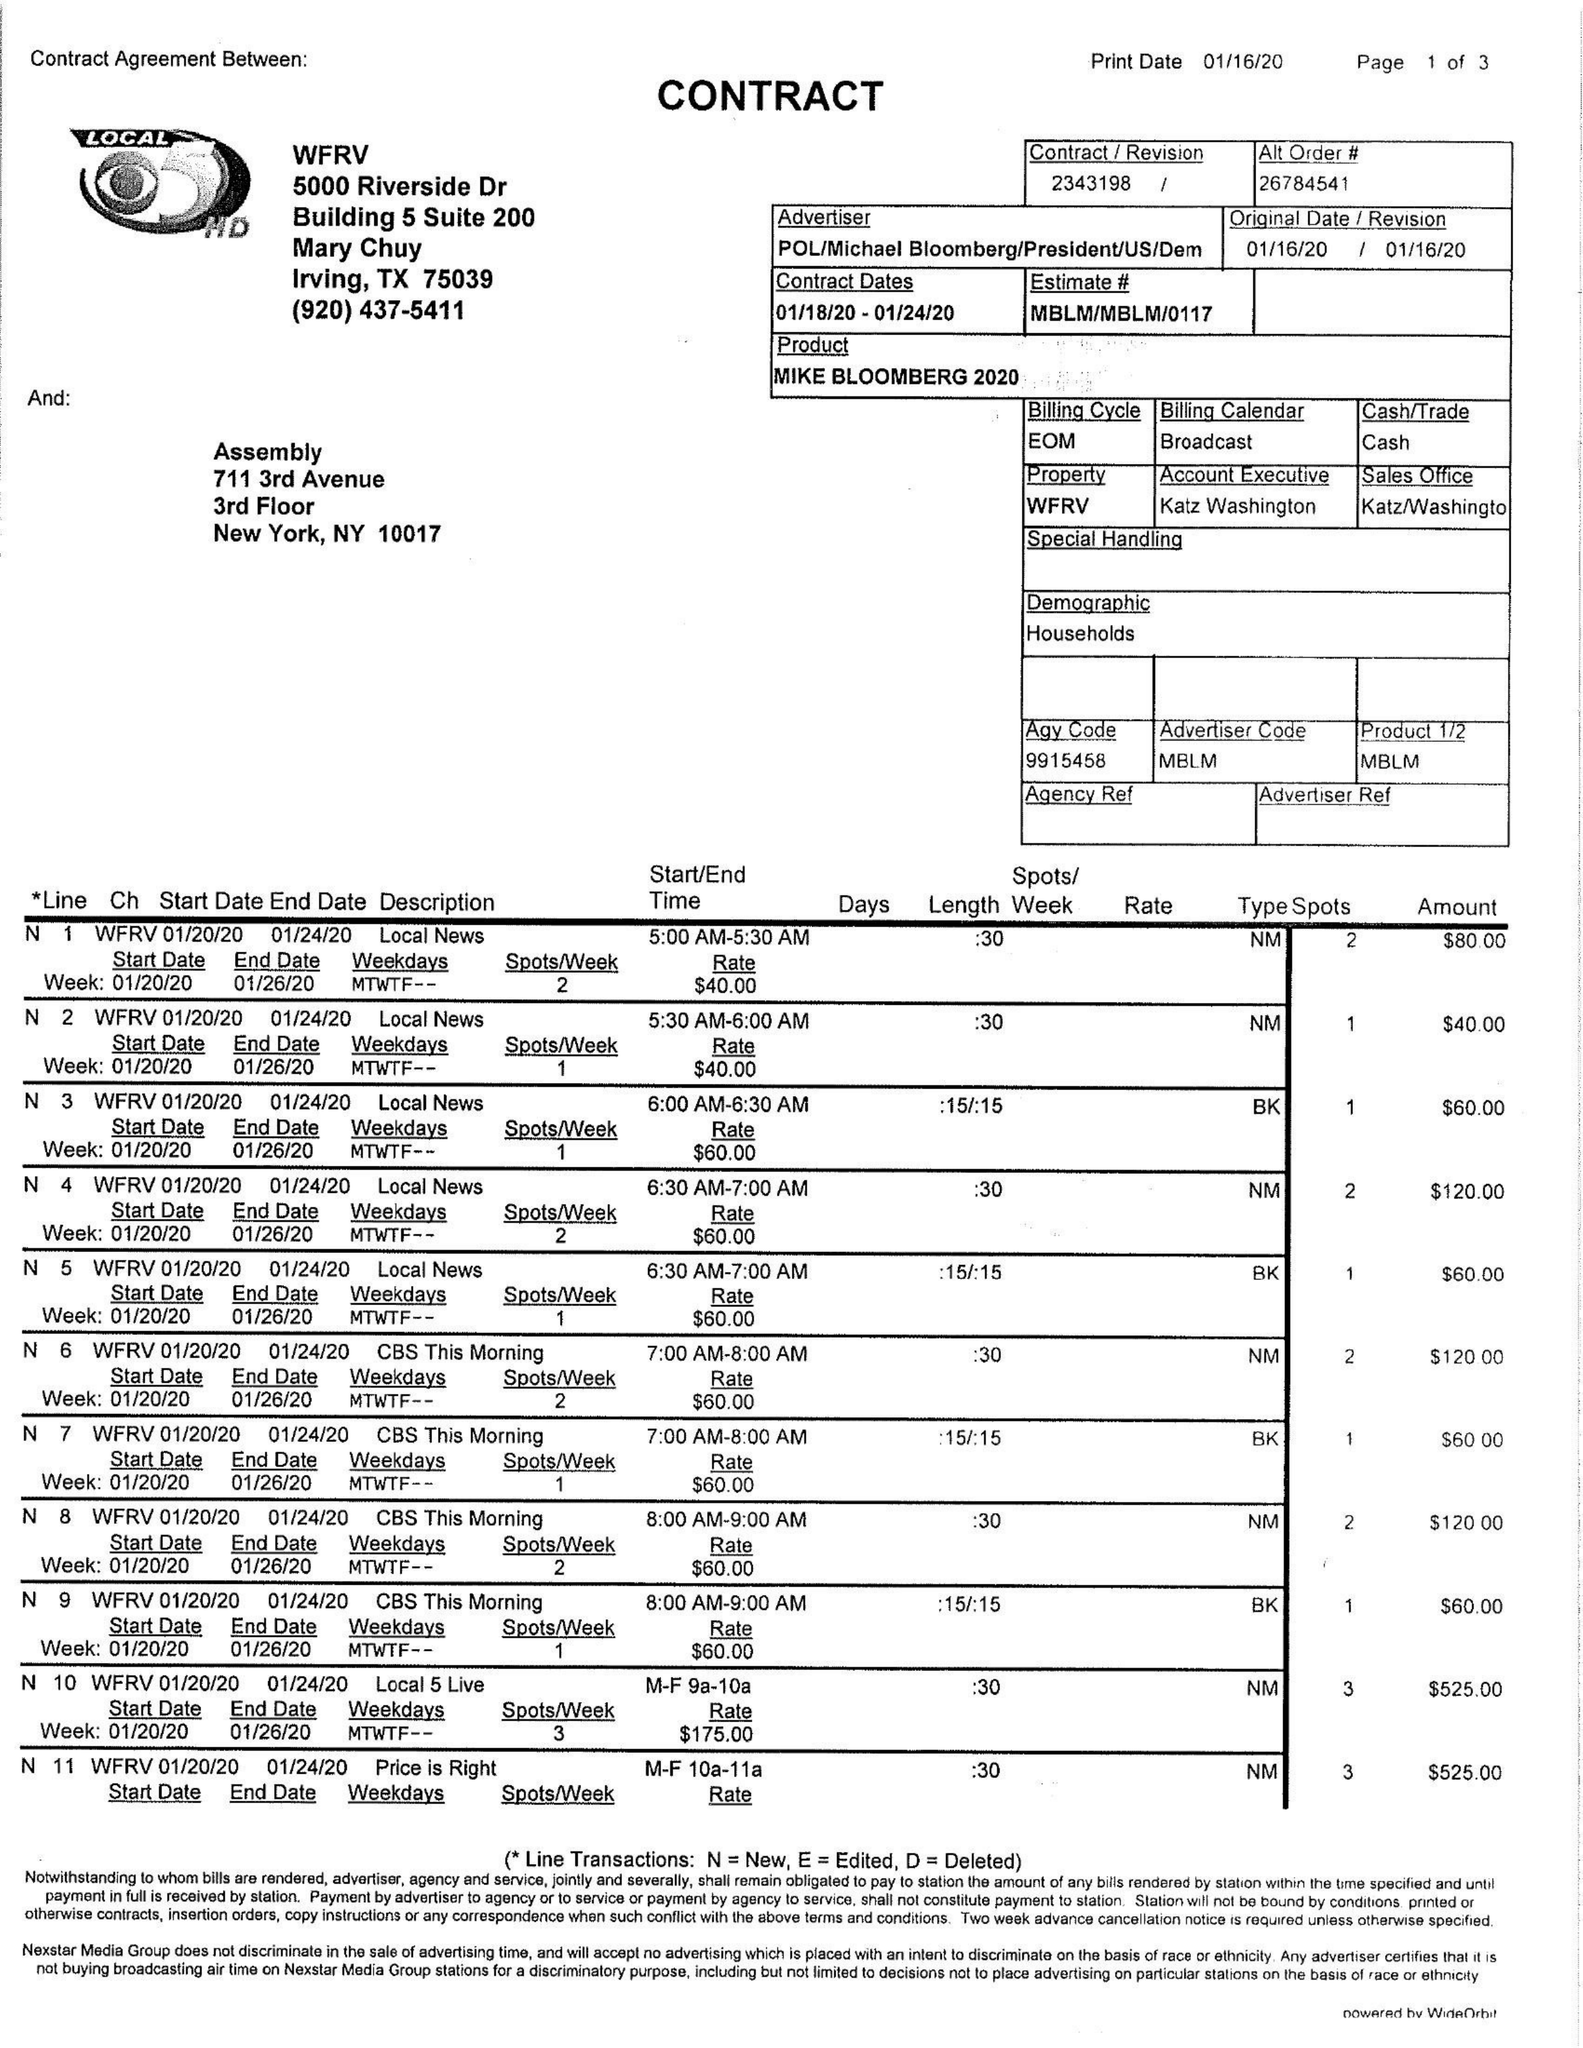What is the value for the flight_to?
Answer the question using a single word or phrase. 01/24/20 